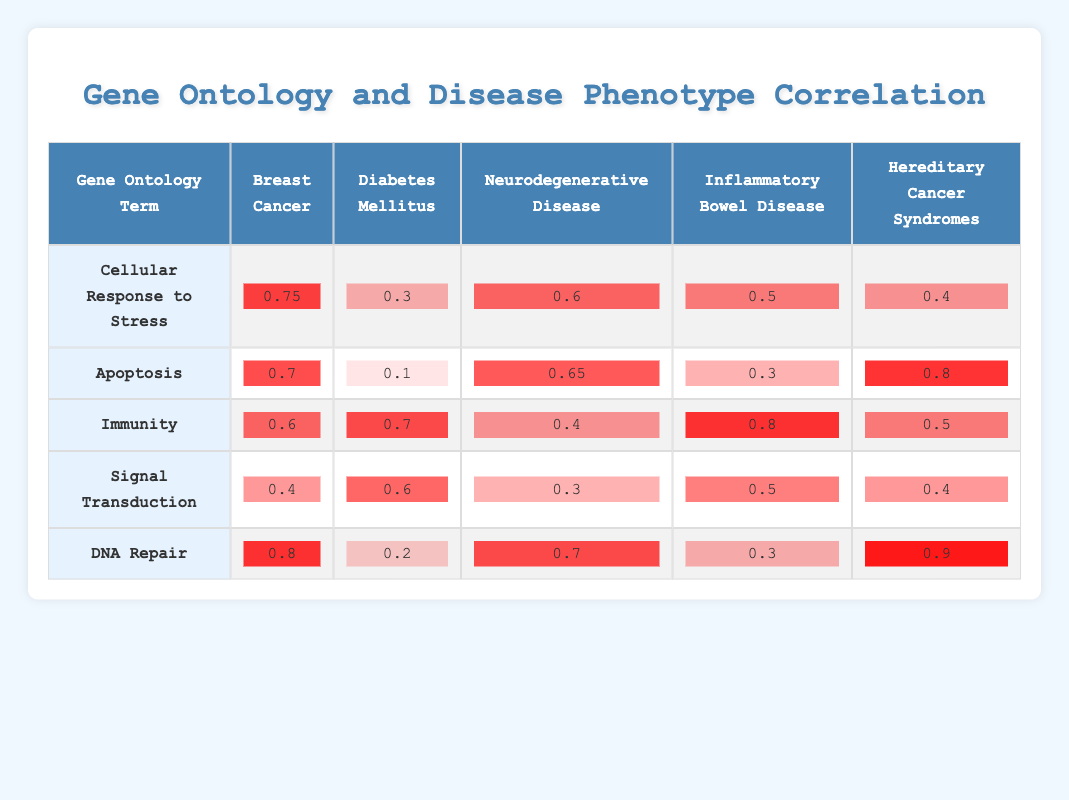What is the correlation value between "Cellular Response to Stress" and "Breast Cancer"? The table shows the correlation value for "Cellular Response to Stress" in the "Breast Cancer" column as 0.75.
Answer: 0.75 Which disease phenotype has the highest correlation with the gene ontology term "DNA Repair"? Referring to the "DNA Repair" row, the highest correlation is with "Hereditary Cancer Syndromes," which has a value of 0.9.
Answer: Hereditary Cancer Syndromes What is the average correlation value for "Apoptosis" across all disease phenotypes? To find the average: (0.7 + 0.1 + 0.65 + 0.3 + 0.8) / 5 = (2.55) / 5 = 0.51.
Answer: 0.51 Is there a correlation value of 0.5 between "Immunity" and "Neurodegenerative Disease"? The table shows the correlation between "Immunity" and "Neurodegenerative Disease" as 0.4, not 0.5. Thus, the statement is false.
Answer: No Which gene ontology term has the lowest correlation with "Diabetes Mellitus"? By checking the "Diabetes Mellitus" column, it is clear that the lowest correlation value is for "Apoptosis," which has a value of 0.1.
Answer: Apoptosis What is the difference in correlation values between "Cellular Response to Stress" and "Signal Transduction" for "Inflammatory Bowel Disease"? For "Inflammatory Bowel Disease," "Cellular Response to Stress" has a correlation of 0.5, while "Signal Transduction" has a correlation of 0.5 as well. Therefore, the difference is 0.5 - 0.5 = 0.
Answer: 0 Which gene ontology term has a higher correlation with "Breast Cancer" than "Diabetes Mellitus"? The terms "Cellular Response to Stress," "Apoptosis," and "DNA Repair" have higher correlation values for "Breast Cancer" (0.75, 0.7, 0.8) compared to "Diabetes Mellitus" (0.3, 0.1, 0.2).
Answer: Cellular Response to Stress, Apoptosis, DNA Repair What is the correlation between "Signal Transduction" and "Hereditary Cancer Syndromes"? The correlation value of "Signal Transduction" with "Hereditary Cancer Syndromes" is listed in the table as 0.4.
Answer: 0.4 